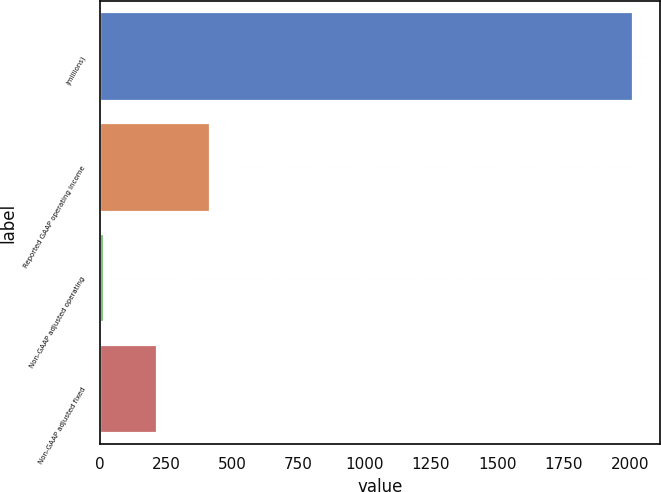Convert chart. <chart><loc_0><loc_0><loc_500><loc_500><bar_chart><fcel>(millions)<fcel>Reported GAAP operating income<fcel>Non-GAAP adjusted operating<fcel>Non-GAAP adjusted fixed<nl><fcel>2014<fcel>414.8<fcel>15<fcel>214.9<nl></chart> 